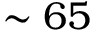Convert formula to latex. <formula><loc_0><loc_0><loc_500><loc_500>\sim 6 5</formula> 